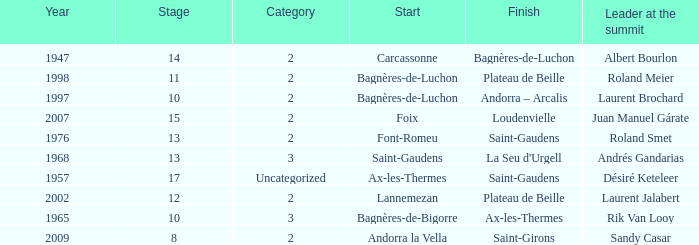Give the Finish for a Stage that is larger than 15 Saint-Gaudens. 